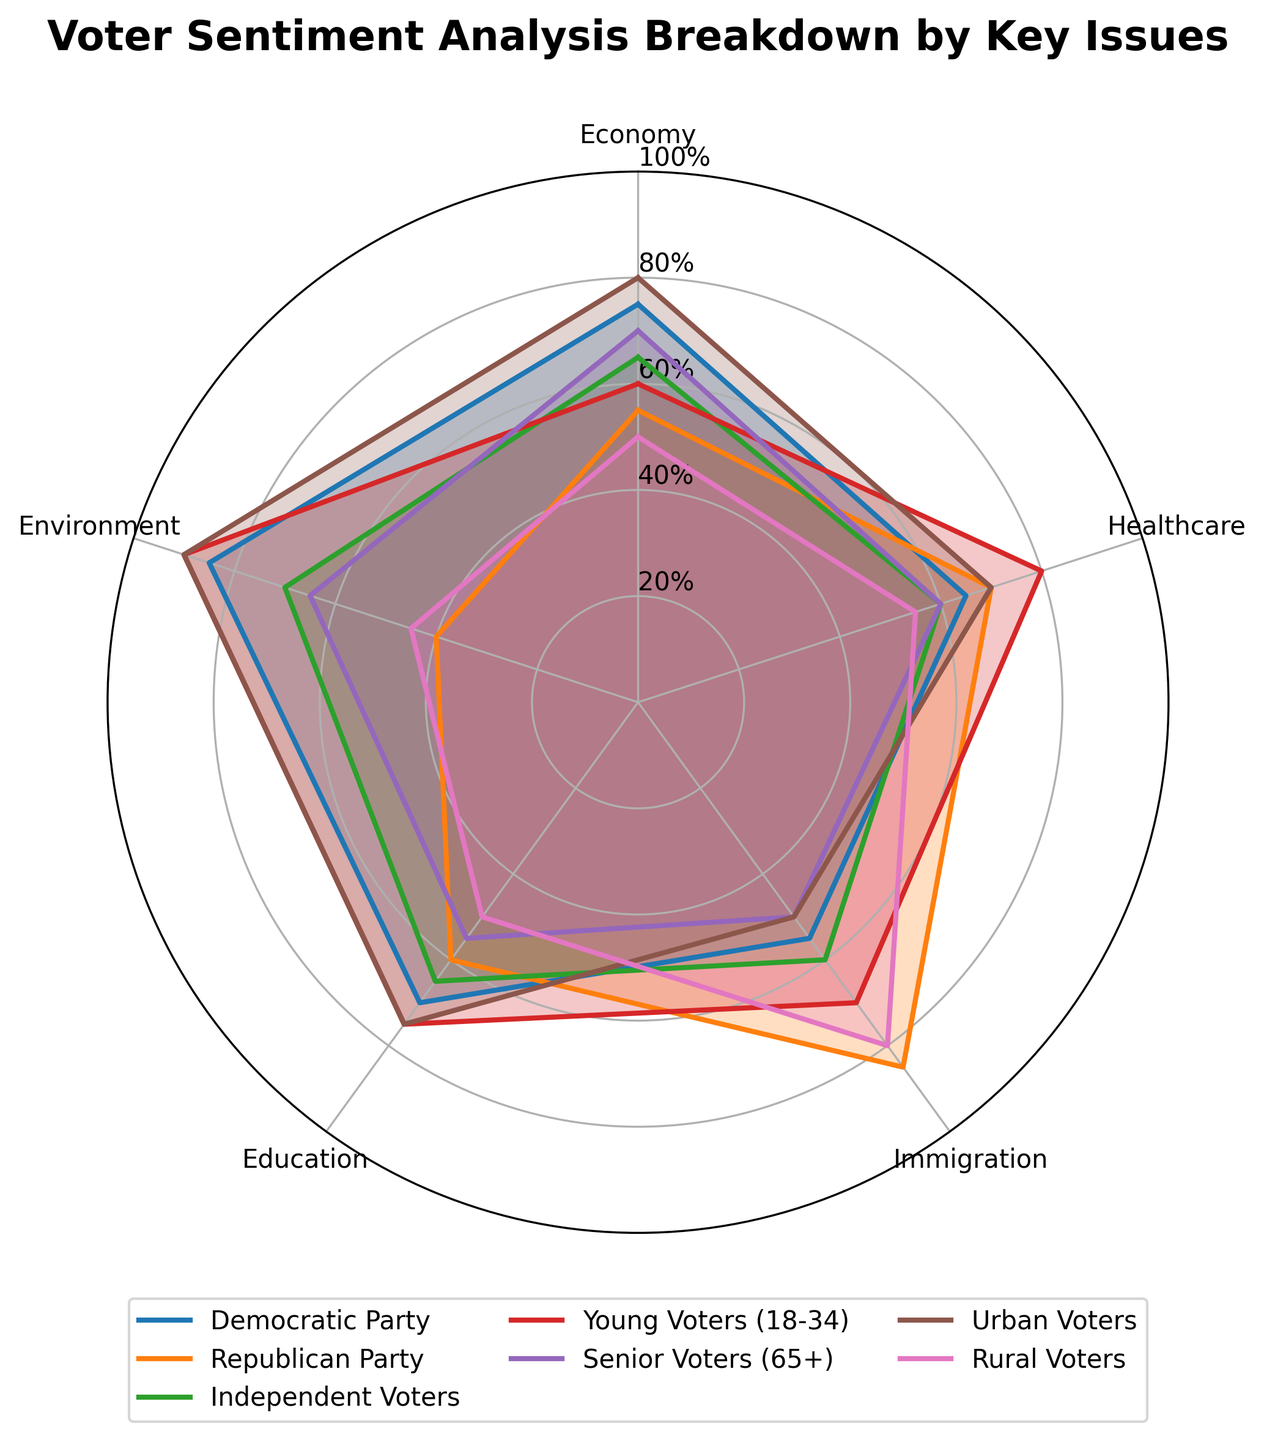What is the title of the radar chart? The title is usually located at the top of the radar chart. In this case, it reads "Voter Sentiment Analysis Breakdown by Key Issues".
Answer: Voter Sentiment Analysis Breakdown by Key Issues Which group shows the highest sentiment for Environment? By looking at the values for Environment across all groups, we find that "Young Voters (18-34)" has the highest sentiment at 90.
Answer: Young Voters (18-34) What is the range of the y-axis in the chart? By inspecting the y-axis, which shows percentage ticks, we can see they range from 0% to 100%.
Answer: 0% to 100% Which issue has the widest sentiment range among all groups? To determine this, we calculate the range (max - min) for each issue. Environment's range is 90 - 40 = 50, Economy's range is 80 - 50 = 30, Healthcare's range is 80 - 55 = 25, Immigration's range is 85 - 50 = 35, Education's range is 75 - 50 = 25. The widest sentiment range is for Environment.
Answer: Environment Which group has nearly equal sentiment on Economy and Healthcare? By comparing the values for Economy and Healthcare across groups, "Independent Voters" has nearly equal values with Economy at 65 and Healthcare at 60.
Answer: Independent Voters How does the sentiment of Rural Voters compare to Urban Voters on Immigration? We need to compare the values for Immigration. Rural Voters have 80, while Urban Voters have 50.
Answer: Rural Voters have a higher sentiment on Immigration than Urban Voters What is the average sentiment of Democratic Party on all issues? Calculate the average of Democratic Party's values: (75 + 65 + 55 + 70 + 85) / 5 = 70.
Answer: 70 Which two groups have the closest sentiment values for Healthcare? To find this, we compare Healthcare sentiment scores: Democratic Party (65), Republican Party (70), Independent Voters (60), Young Voters (80), Senior Voters (60), Urban Voters (70), Rural Voters (55). "Independent Voters" and "Senior Voters" both have 60.
Answer: Independent Voters and Senior Voters Which issue is the distance maximized between Young Voters (18-34) and Senior Voters (65+)? We compute the absolute difference for each issue: Economy: 60-70 = 10, Healthcare: 80-60 = 20, Immigration: 70-50 = 20, Education: 75-55 = 20, Environment: 90-65 = 25. The maximum distance is for Environment, 25.
Answer: Environment 